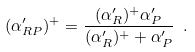Convert formula to latex. <formula><loc_0><loc_0><loc_500><loc_500>( \alpha _ { R P } ^ { \prime } ) ^ { + } = \frac { ( \alpha _ { R } ^ { \prime } ) ^ { + } \alpha _ { P } ^ { \prime } } { ( \alpha _ { R } ^ { \prime } ) ^ { + } + \alpha _ { P } ^ { \prime } } \ .</formula> 